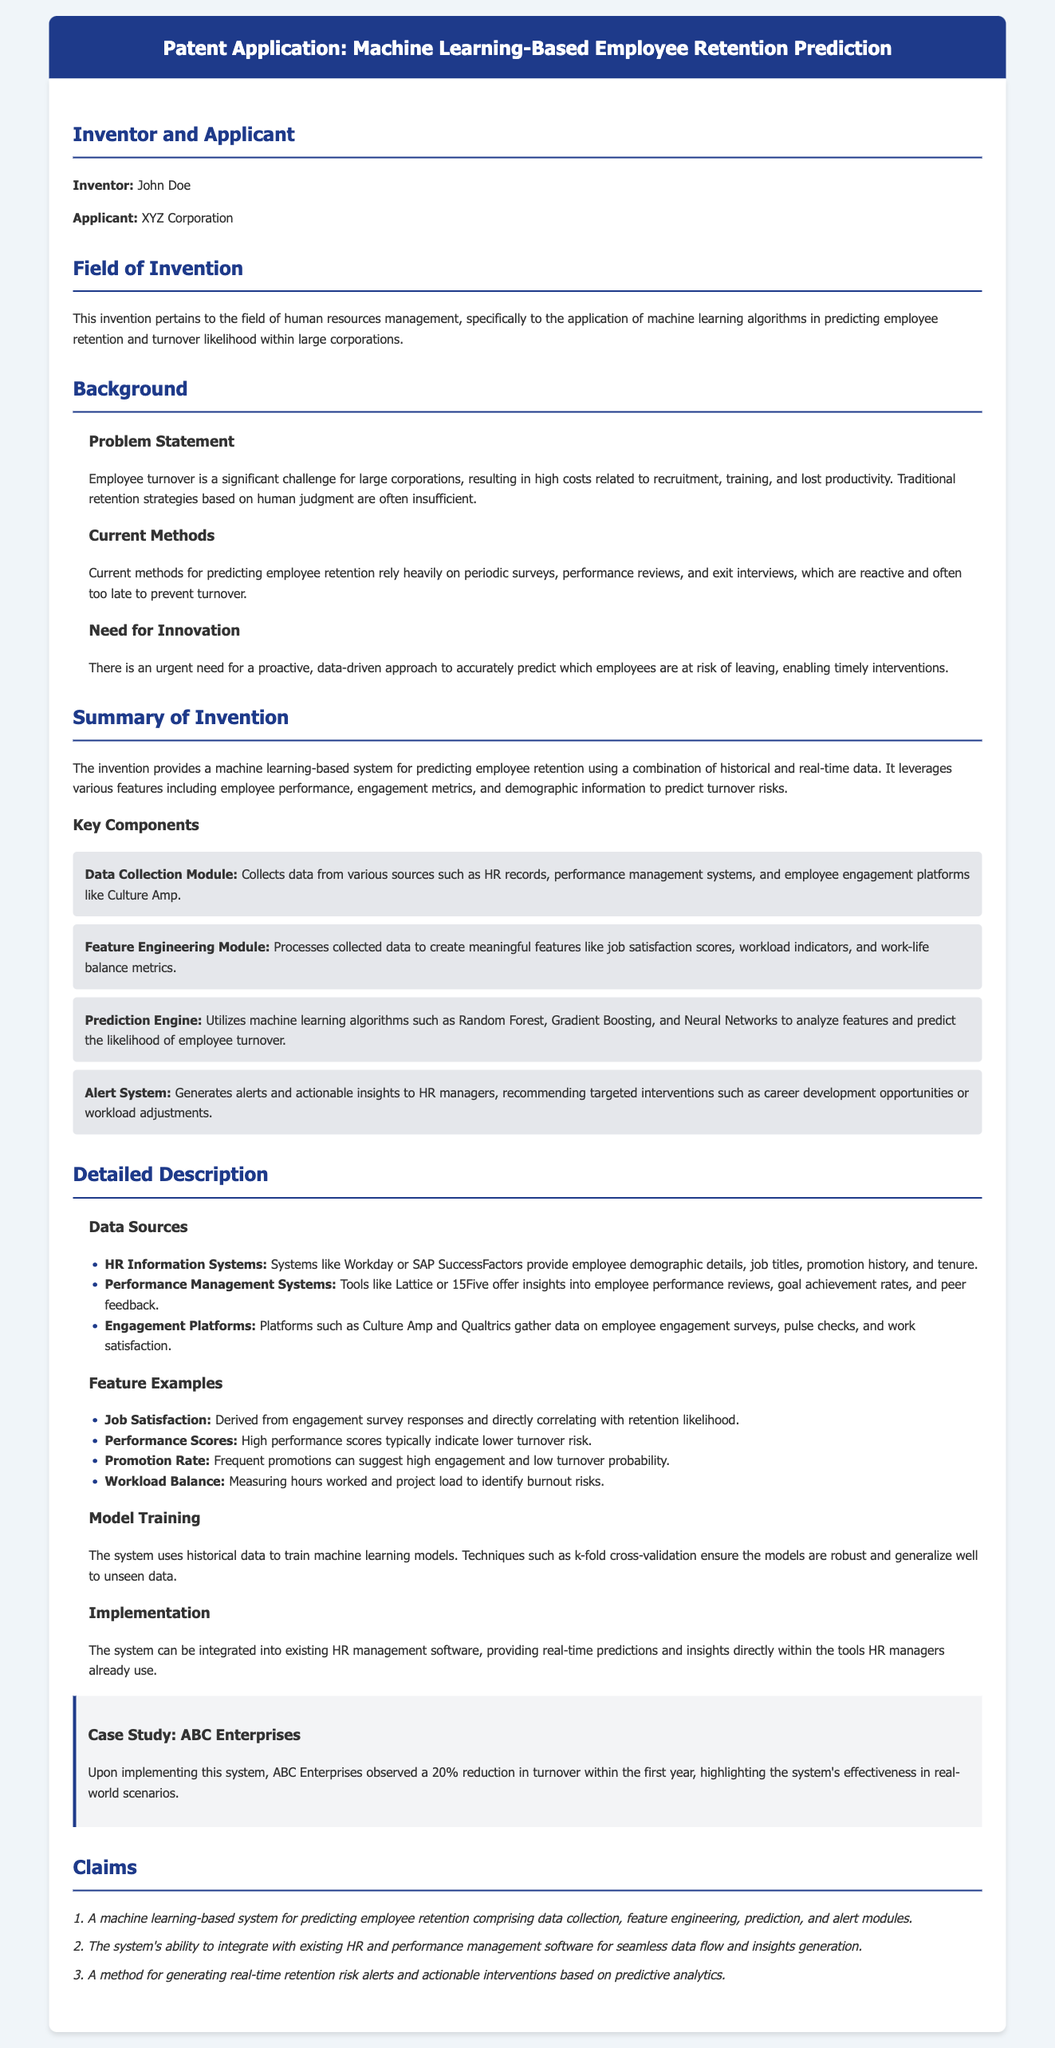What is the name of the inventor? The inventor's name is explicitly mentioned in the document as John Doe.
Answer: John Doe What is the applicant's name? The applicant is listed as XYZ Corporation in the document.
Answer: XYZ Corporation What is the field of invention? The document specifies that the field of invention pertains to human resources management and machine learning.
Answer: Human resources management, machine learning What is one key component of the invention? The document lists several key components; one example is the Data Collection Module.
Answer: Data Collection Module What is the percentage reduction in turnover observed by ABC Enterprises? The case study provides a specific statistic regarding turnover reduction, which is stated as 20%.
Answer: 20% What is a current method for predicting employee retention mentioned in the document? The document lists performance reviews as one of the current methods used for this purpose.
Answer: Performance reviews Which algorithms are used in the Prediction Engine? The document names specific algorithms that are utilized, including Random Forest, Gradient Boosting, and Neural Networks.
Answer: Random Forest, Gradient Boosting, Neural Networks How does the system generate alerts for HR managers? The system generates alerts and actionable insights based on its predictive analytics capabilities as described in the claims section.
Answer: Predictive analytics What is the main purpose of the invention? The summary states that the main purpose is to predict employee retention and turnover likelihood.
Answer: Predict employee retention and turnover likelihood 